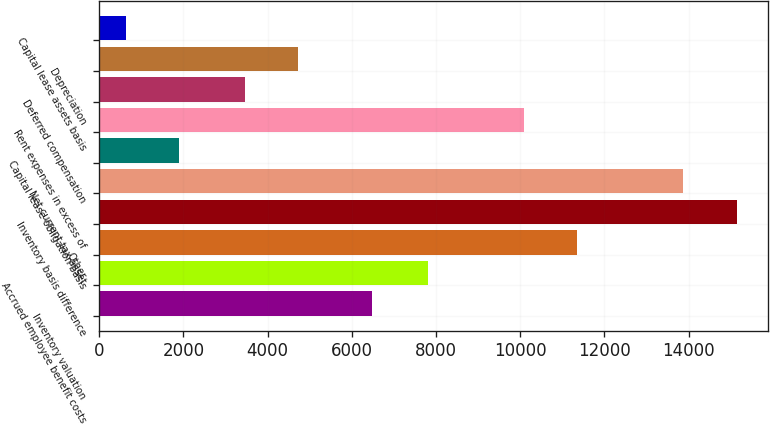Convert chart to OTSL. <chart><loc_0><loc_0><loc_500><loc_500><bar_chart><fcel>Inventory valuation<fcel>Accrued employee benefit costs<fcel>Other<fcel>Inventory basis difference<fcel>Net current tax asset<fcel>Capital lease obligation basis<fcel>Rent expenses in excess of<fcel>Deferred compensation<fcel>Depreciation<fcel>Capital lease assets basis<nl><fcel>6485<fcel>7803<fcel>11351.7<fcel>15142.8<fcel>13879.1<fcel>1899.7<fcel>10088<fcel>3453<fcel>4716.7<fcel>636<nl></chart> 